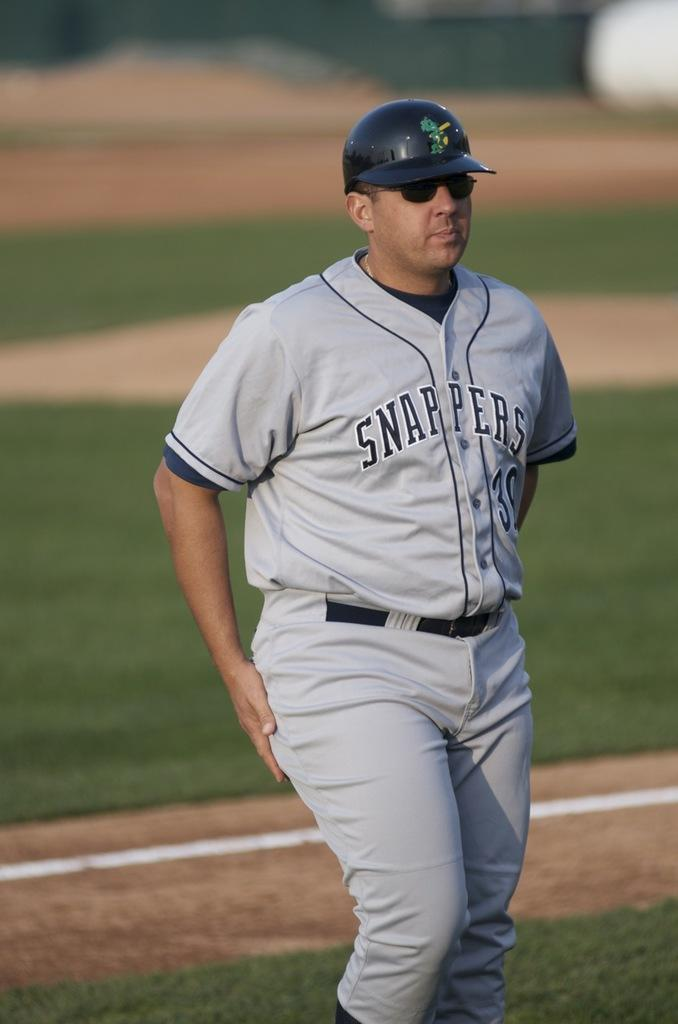<image>
Create a compact narrative representing the image presented. A baseball player with the Snappers is walking on the field. 